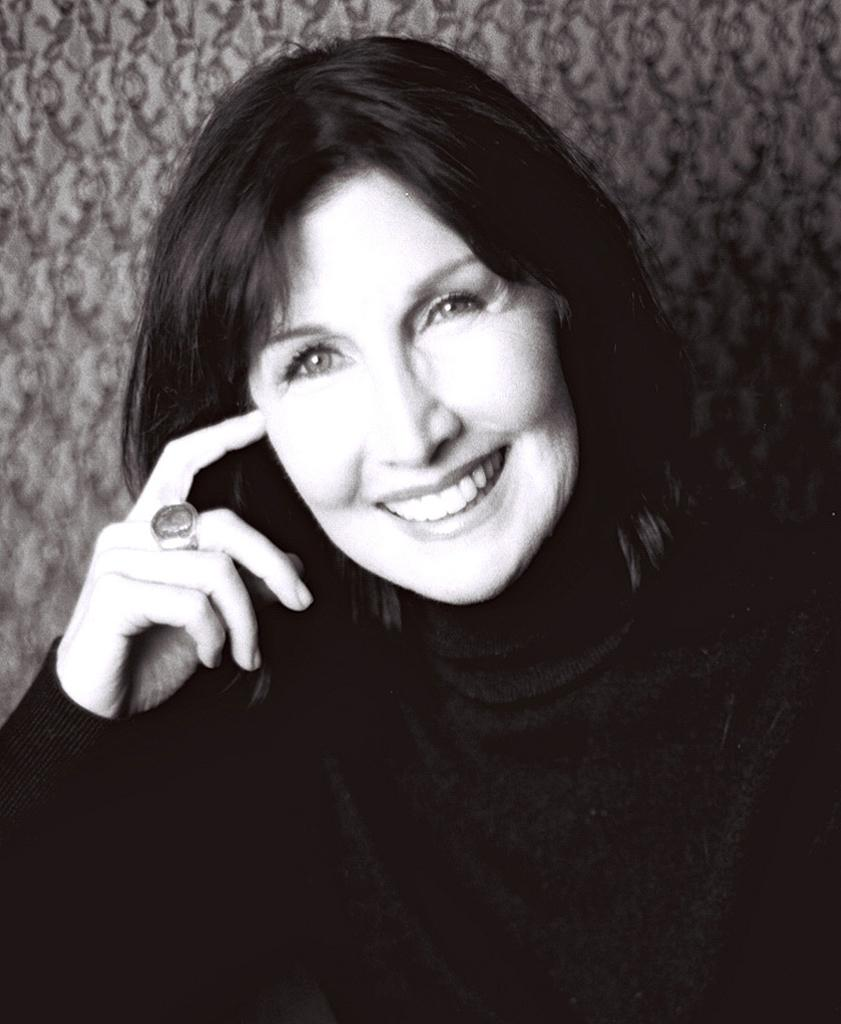Who is the main subject in the image? There is a lady in the image. What is the lady wearing? The lady is wearing a black dress. Can you describe any accessories the lady is wearing? The lady has a ring on her finger. What type of footwear is the lady wearing in the image? The provided facts do not mention any footwear, so we cannot determine the type of footwear the lady is wearing. 